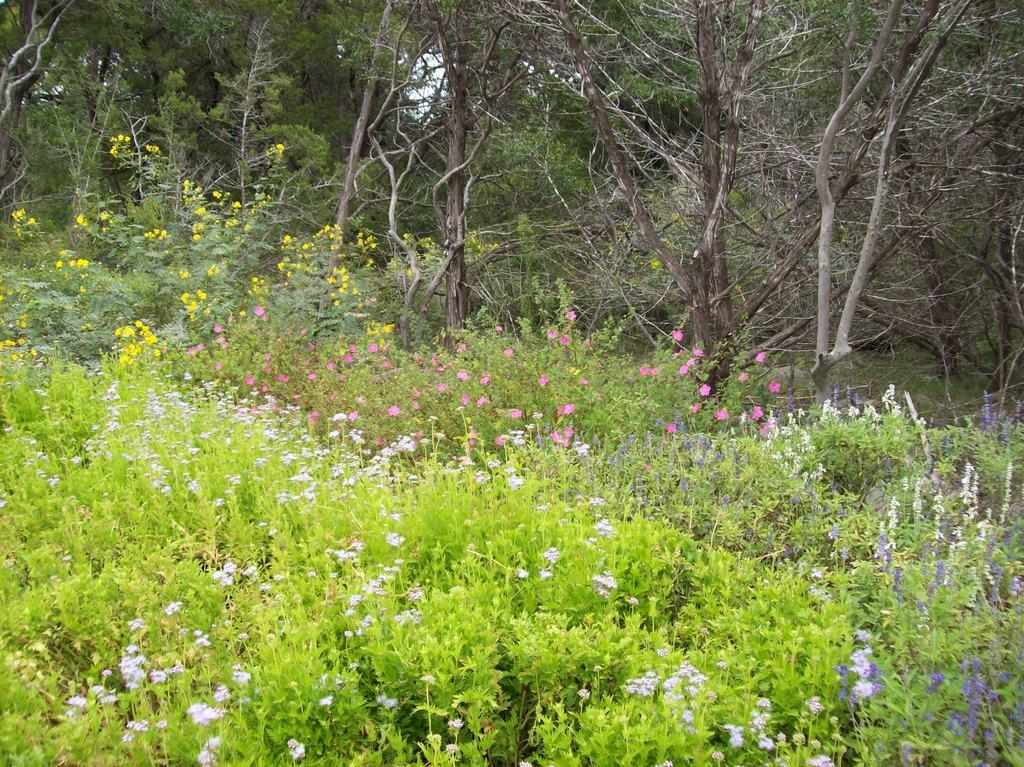What type of plants are in the foreground of the image? There are flower plants in the foreground of the image. What other types of plants can be seen in the image? There are trees visible behind the flower plants. What time of day is it in the image, and what type of cream is being used? The provided facts do not mention the time of day or the presence of any cream in the image. 